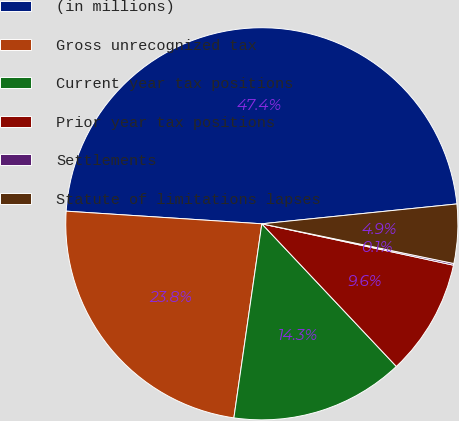Convert chart to OTSL. <chart><loc_0><loc_0><loc_500><loc_500><pie_chart><fcel>(in millions)<fcel>Gross unrecognized tax<fcel>Current year tax positions<fcel>Prior year tax positions<fcel>Settlements<fcel>Statute of limitations lapses<nl><fcel>47.36%<fcel>23.75%<fcel>14.31%<fcel>9.58%<fcel>0.14%<fcel>4.86%<nl></chart> 